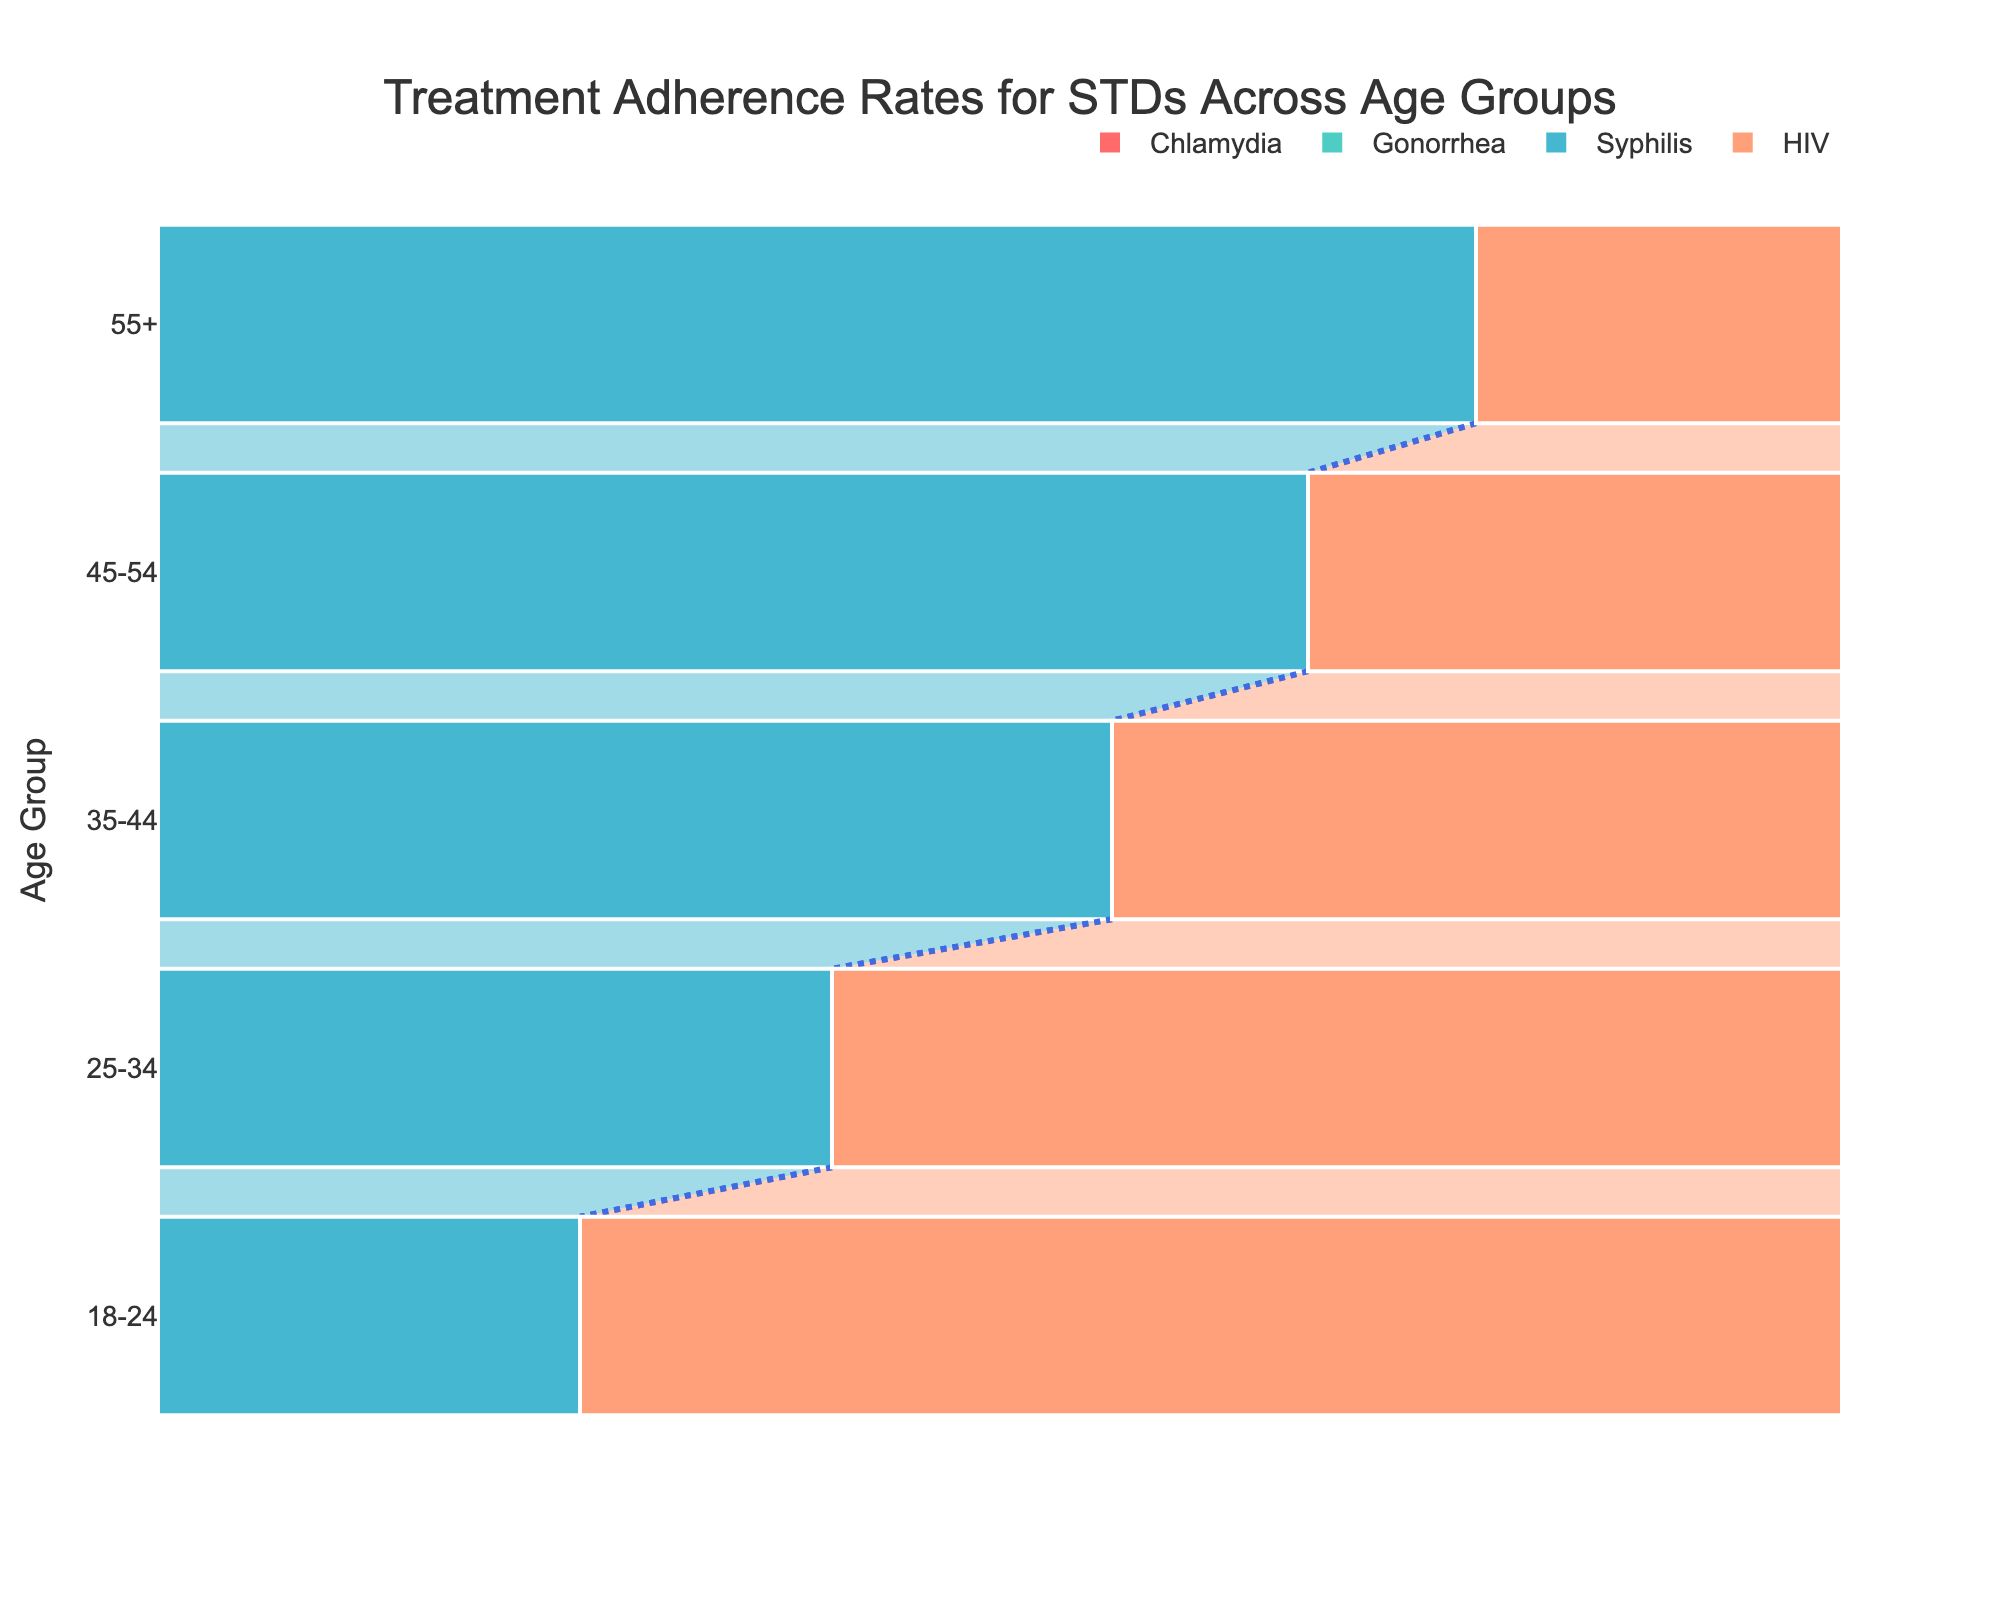What's the title of the chart? The title is displayed at the top center of the chart.
Answer: Treatment Adherence Rates for STDs Across Age Groups What is the adherence rate for Chlamydia in the 18-24 age group? Refer to the bar corresponding to Chlamydia in the 18-24 age group.
Answer: 85% Which age group has the highest treatment adherence rate for HIV? Look for the age group with the tallest bar for HIV.
Answer: 55+ How does the adherence rate for Syphilis in the 25-34 age group compare to that in the 35-44 age group? Compare the heights of the bars for Syphilis between these two age groups.
Answer: 83% vs. 87% Which STD has the lowest treatment adherence rate in the 18-24 age group? Identify the shortest bar within the 18-24 age group across all STDs.
Answer: Syphilis What's the difference in adherence rates for Gonorrhea between the 18-24 and 55+ age groups? Subtract the adherence rate for the 18-24 group from the 55+ group (95% - 82%).
Answer: 13% What is the average adherence rate for all STDs in the 45-54 age group? Average the adherence rates for Chlamydia (94%), Gonorrhea (93%), Syphilis (91%), and HIV (97%). Calculation: (94% + 93% + 91% + 97%) / 4 = 93.75%
Answer: 93.75% Which STD shows the most consistent adherence rate across all age groups? Identify the STD with the least variation in adherence rates across all age groups. Visual inspection shows HIV has the smallest range.
Answer: HIV Compare the overall trend in adherence rates across age groups? Observe the trend of the adherence rates for all STDs from the 18-24 age group to the 55+ age group.
Answer: Increasing Is there any age group where the adherence rate for Chlamydia is lower than 90%? Check each bar for Chlamydia to see if any are below 90%.
Answer: Yes, 18-24 